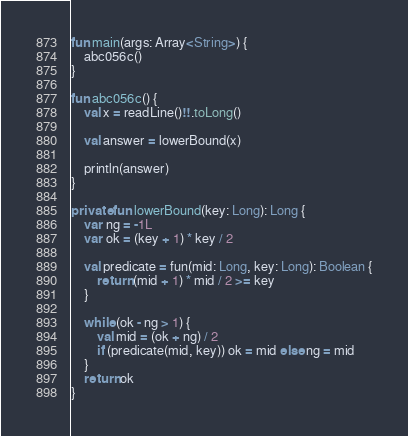<code> <loc_0><loc_0><loc_500><loc_500><_Kotlin_>fun main(args: Array<String>) {
    abc056c()
}

fun abc056c() {
    val x = readLine()!!.toLong()

    val answer = lowerBound(x)

    println(answer)
}

private fun lowerBound(key: Long): Long {
    var ng = -1L
    var ok = (key + 1) * key / 2

    val predicate = fun(mid: Long, key: Long): Boolean {
        return (mid + 1) * mid / 2 >= key
    }

    while (ok - ng > 1) {
        val mid = (ok + ng) / 2
        if (predicate(mid, key)) ok = mid else ng = mid
    }
    return ok
}
</code> 